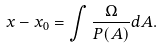Convert formula to latex. <formula><loc_0><loc_0><loc_500><loc_500>x - x _ { 0 } = \int \frac { \Omega } { P ( A ) } d A .</formula> 